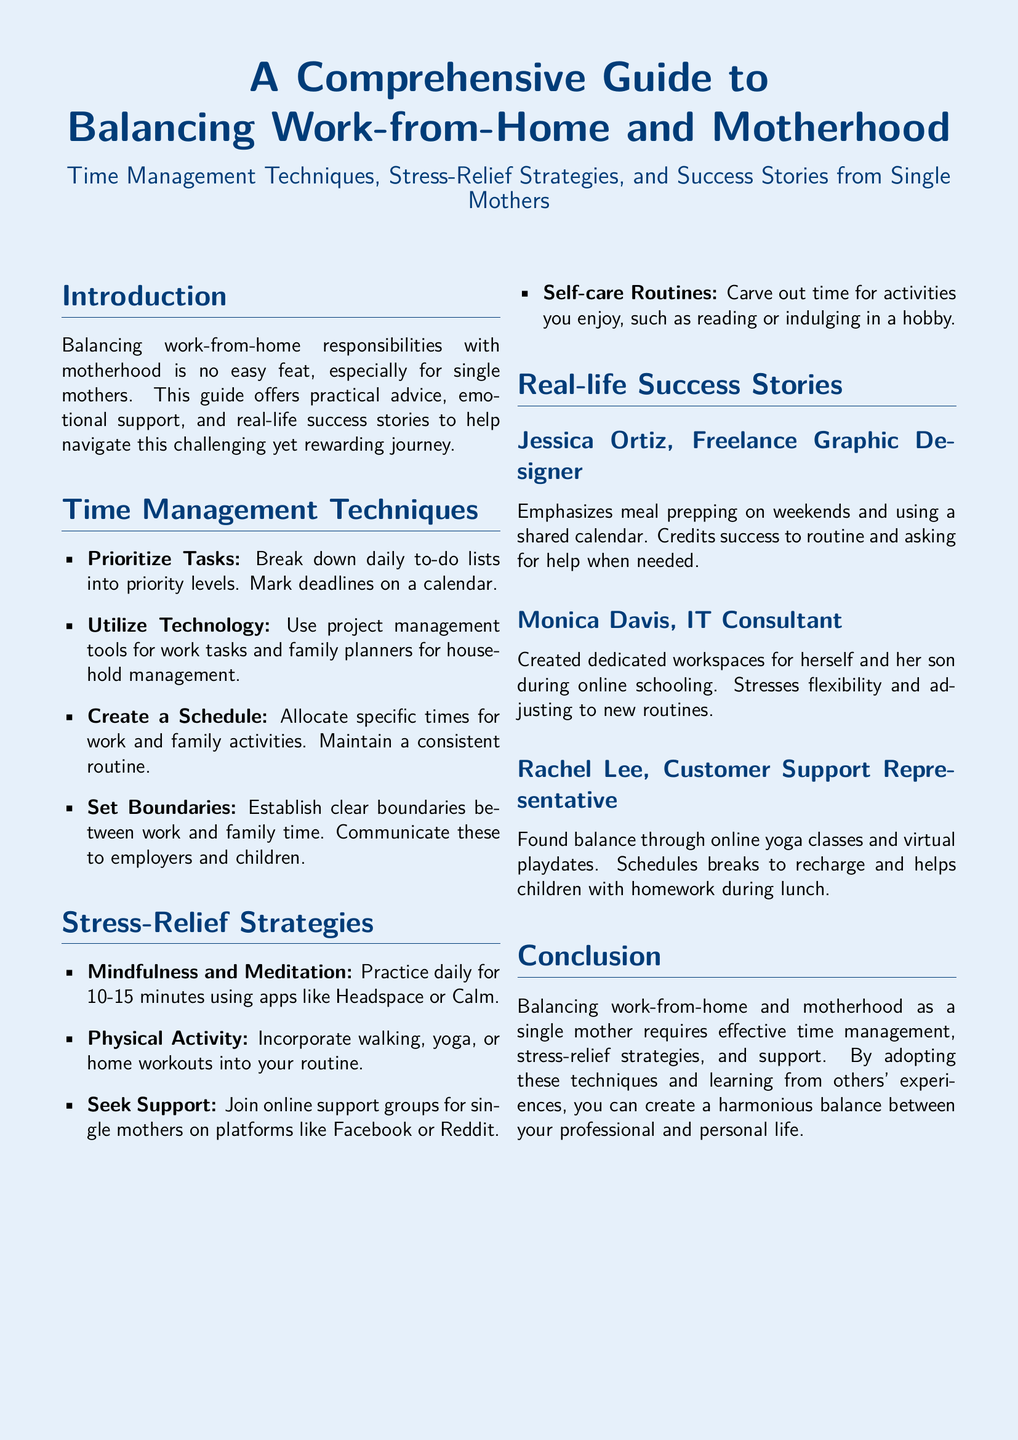What are some time management techniques mentioned? The question asks for a specific section of the document detailing time management techniques, which include prioritizing tasks, utilizing technology, creating a schedule, and setting boundaries.
Answer: Prioritize Tasks, Utilize Technology, Create a Schedule, Set Boundaries Who is Jessica Ortiz? This question retrieves specific information from the success stories section about a featured individual, highlighting her role and some practices during motherhood.
Answer: Freelance Graphic Designer What is suggested for stress relief? The question seeks to summarize overall recommendations to manage stress outlined in the document, specifically strategies provided.
Answer: Mindfulness and Meditation, Physical Activity, Seek Support, Self-care Routines How long should mindfulness practice last? This question requires specific detail from the stress-relief strategies presumably suggesting a duration for mindfulness, which is explicitly given in the text.
Answer: 10-15 minutes What is a common tool mentioned for managing tasks? The question looks for specific technological tools referenced for task management, which indicates their importance in the guide.
Answer: Project management tools How does Monica Davis structure her workspace? This question requires a synthesis of information from the success stories section, focusing on the workspace arrangement and its purpose.
Answer: Dedicated workspaces What type of support is recommended to seek? This question prompts the retrieval of a specific category of support mentioned in the strategies, summarizing ideas for community help.
Answer: Online support groups What activity does Rachel Lee incorporate to find balance? The question needs an answer from the success stories, where a specific method used by Rachel Lee to maintain balance can be identified.
Answer: Online yoga classes 